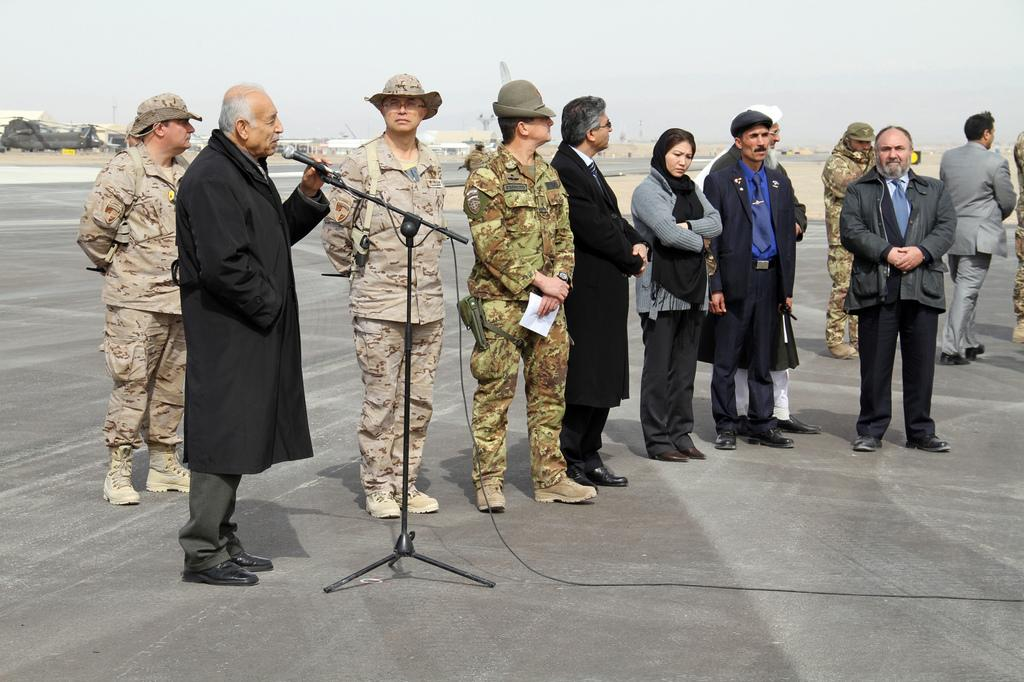What is happening with the group of people in the image? There is a group of people on the ground in the image. What is the man holding in his hand? A man is holding a mic in his hand. What can be seen in the background of the image? There are houses and some objects in the background of the image. What is visible in the sky in the image? The sky is visible in the background of the image. What type of behavior is the group of people exhibiting in the afternoon? The provided facts do not mention the time of day or the behavior of the group of people, so we cannot answer this question based on the information given. 